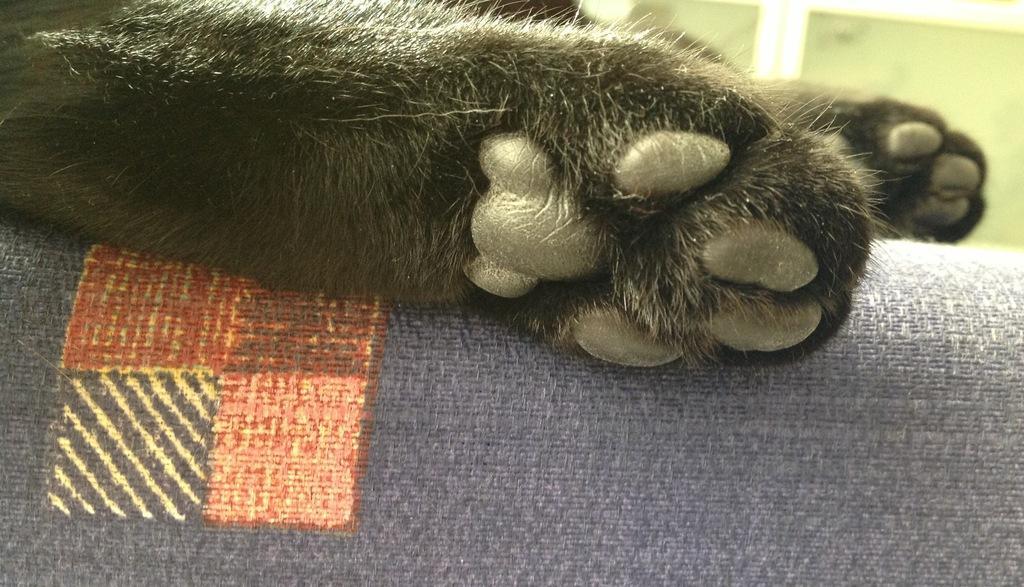In one or two sentences, can you explain what this image depicts? In this picture we can see an animal legs are present on a couch. In the background of the image we can see the wall. 